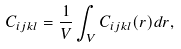<formula> <loc_0><loc_0><loc_500><loc_500>C _ { i j k l } = \frac { 1 } { V } \int _ { V } C _ { i j k l } ( r ) d r ,</formula> 